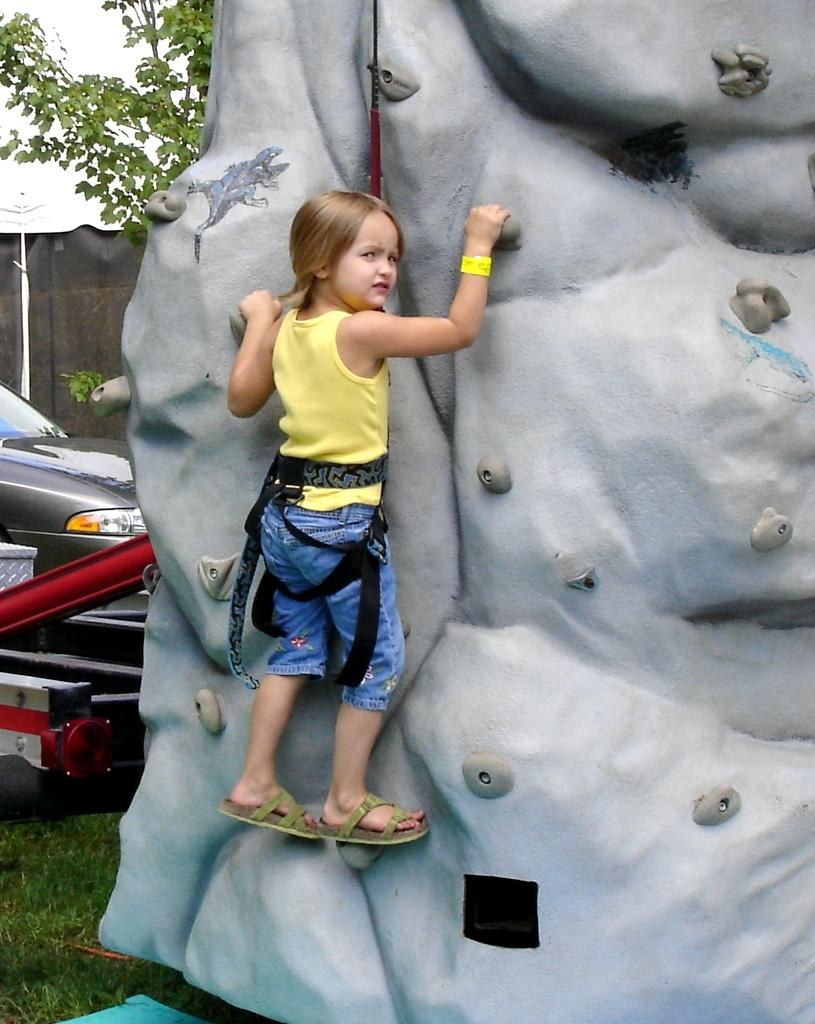What is the main subject of the image? There is a child in the image. What activity is the child engaged in? The child is doing rock climbing. What can be seen in the background of the image? There are trees, walls, a motor vehicle, and grass in the background of the image. What type of star can be seen in the image? There is no star visible in the image; it features a child rock climbing with a background of trees, walls, a motor vehicle, and grass. 